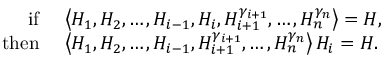Convert formula to latex. <formula><loc_0><loc_0><loc_500><loc_500>\begin{array} { r l } { i f } & { \left \langle H _ { 1 } , H _ { 2 } , \dots , H _ { i - 1 } , H _ { i } , H _ { i + 1 } ^ { \gamma _ { i + 1 } } , \dots , H _ { n } ^ { \gamma _ { n } } \right \rangle = H , } \\ { t h e n } & { \left \langle H _ { 1 } , H _ { 2 } , \dots , H _ { i - 1 } , H _ { i + 1 } ^ { \gamma _ { i + 1 } } , \dots , H _ { n } ^ { \gamma _ { n } } \right \rangle H _ { i } = H . } \end{array}</formula> 